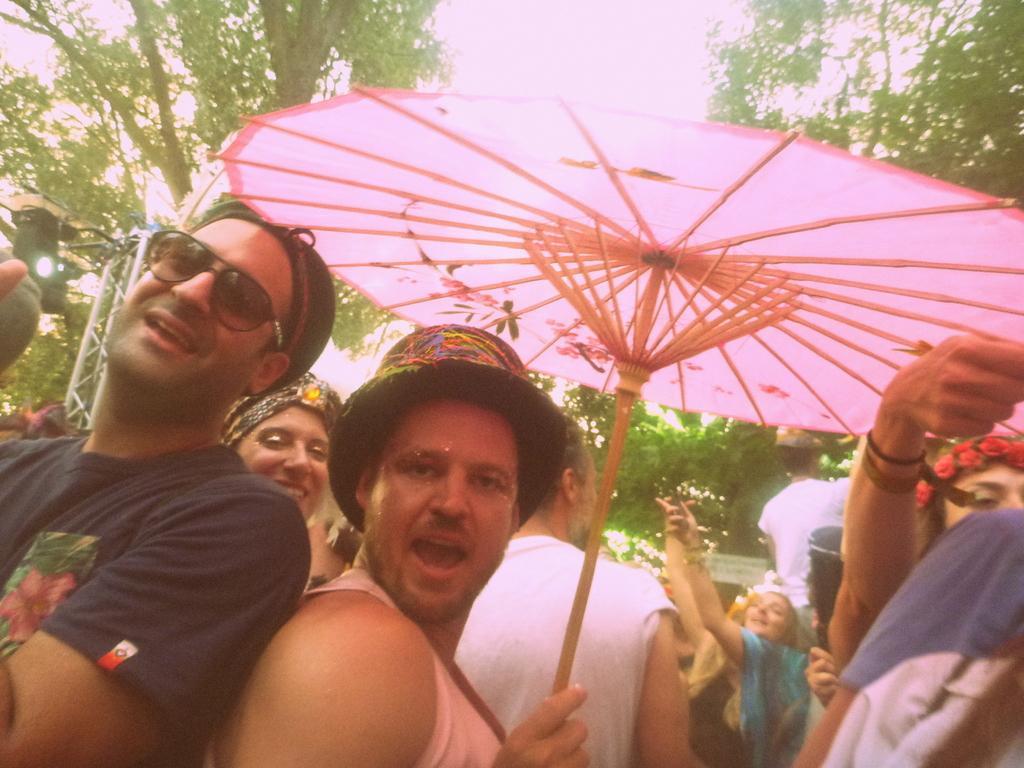Please provide a concise description of this image. This picture is clicked outside. In the foreground we can see the group of persons. In the center there is a man wearing hat and holding a pink color umbrella. In the background we can see the sky, trees, metal rods and some other objects. 